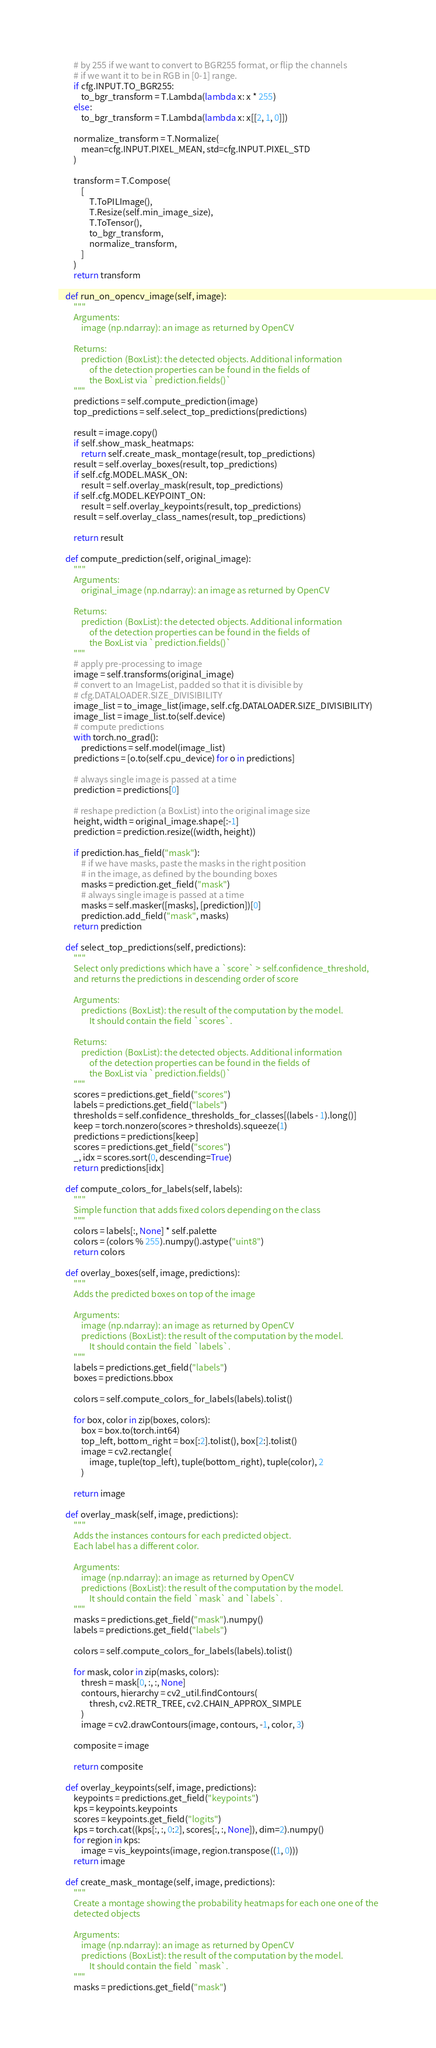<code> <loc_0><loc_0><loc_500><loc_500><_Python_>        # by 255 if we want to convert to BGR255 format, or flip the channels
        # if we want it to be in RGB in [0-1] range.
        if cfg.INPUT.TO_BGR255:
            to_bgr_transform = T.Lambda(lambda x: x * 255)
        else:
            to_bgr_transform = T.Lambda(lambda x: x[[2, 1, 0]])

        normalize_transform = T.Normalize(
            mean=cfg.INPUT.PIXEL_MEAN, std=cfg.INPUT.PIXEL_STD
        )

        transform = T.Compose(
            [
                T.ToPILImage(),
                T.Resize(self.min_image_size),
                T.ToTensor(),
                to_bgr_transform,
                normalize_transform,
            ]
        )
        return transform

    def run_on_opencv_image(self, image):
        """
        Arguments:
            image (np.ndarray): an image as returned by OpenCV

        Returns:
            prediction (BoxList): the detected objects. Additional information
                of the detection properties can be found in the fields of
                the BoxList via `prediction.fields()`
        """
        predictions = self.compute_prediction(image)
        top_predictions = self.select_top_predictions(predictions)

        result = image.copy()
        if self.show_mask_heatmaps:
            return self.create_mask_montage(result, top_predictions)
        result = self.overlay_boxes(result, top_predictions)
        if self.cfg.MODEL.MASK_ON:
            result = self.overlay_mask(result, top_predictions)
        if self.cfg.MODEL.KEYPOINT_ON:
            result = self.overlay_keypoints(result, top_predictions)
        result = self.overlay_class_names(result, top_predictions)

        return result

    def compute_prediction(self, original_image):
        """
        Arguments:
            original_image (np.ndarray): an image as returned by OpenCV

        Returns:
            prediction (BoxList): the detected objects. Additional information
                of the detection properties can be found in the fields of
                the BoxList via `prediction.fields()`
        """
        # apply pre-processing to image
        image = self.transforms(original_image)
        # convert to an ImageList, padded so that it is divisible by
        # cfg.DATALOADER.SIZE_DIVISIBILITY
        image_list = to_image_list(image, self.cfg.DATALOADER.SIZE_DIVISIBILITY)
        image_list = image_list.to(self.device)
        # compute predictions
        with torch.no_grad():
            predictions = self.model(image_list)
        predictions = [o.to(self.cpu_device) for o in predictions]

        # always single image is passed at a time
        prediction = predictions[0]

        # reshape prediction (a BoxList) into the original image size
        height, width = original_image.shape[:-1]
        prediction = prediction.resize((width, height))

        if prediction.has_field("mask"):
            # if we have masks, paste the masks in the right position
            # in the image, as defined by the bounding boxes
            masks = prediction.get_field("mask")
            # always single image is passed at a time
            masks = self.masker([masks], [prediction])[0]
            prediction.add_field("mask", masks)
        return prediction

    def select_top_predictions(self, predictions):
        """
        Select only predictions which have a `score` > self.confidence_threshold,
        and returns the predictions in descending order of score

        Arguments:
            predictions (BoxList): the result of the computation by the model.
                It should contain the field `scores`.

        Returns:
            prediction (BoxList): the detected objects. Additional information
                of the detection properties can be found in the fields of
                the BoxList via `prediction.fields()`
        """
        scores = predictions.get_field("scores")
        labels = predictions.get_field("labels")
        thresholds = self.confidence_thresholds_for_classes[(labels - 1).long()]
        keep = torch.nonzero(scores > thresholds).squeeze(1)
        predictions = predictions[keep]
        scores = predictions.get_field("scores")
        _, idx = scores.sort(0, descending=True)
        return predictions[idx]

    def compute_colors_for_labels(self, labels):
        """
        Simple function that adds fixed colors depending on the class
        """
        colors = labels[:, None] * self.palette
        colors = (colors % 255).numpy().astype("uint8")
        return colors

    def overlay_boxes(self, image, predictions):
        """
        Adds the predicted boxes on top of the image

        Arguments:
            image (np.ndarray): an image as returned by OpenCV
            predictions (BoxList): the result of the computation by the model.
                It should contain the field `labels`.
        """
        labels = predictions.get_field("labels")
        boxes = predictions.bbox

        colors = self.compute_colors_for_labels(labels).tolist()

        for box, color in zip(boxes, colors):
            box = box.to(torch.int64)
            top_left, bottom_right = box[:2].tolist(), box[2:].tolist()
            image = cv2.rectangle(
                image, tuple(top_left), tuple(bottom_right), tuple(color), 2
            )

        return image

    def overlay_mask(self, image, predictions):
        """
        Adds the instances contours for each predicted object.
        Each label has a different color.

        Arguments:
            image (np.ndarray): an image as returned by OpenCV
            predictions (BoxList): the result of the computation by the model.
                It should contain the field `mask` and `labels`.
        """
        masks = predictions.get_field("mask").numpy()
        labels = predictions.get_field("labels")

        colors = self.compute_colors_for_labels(labels).tolist()

        for mask, color in zip(masks, colors):
            thresh = mask[0, :, :, None]
            contours, hierarchy = cv2_util.findContours(
                thresh, cv2.RETR_TREE, cv2.CHAIN_APPROX_SIMPLE
            )
            image = cv2.drawContours(image, contours, -1, color, 3)

        composite = image

        return composite

    def overlay_keypoints(self, image, predictions):
        keypoints = predictions.get_field("keypoints")
        kps = keypoints.keypoints
        scores = keypoints.get_field("logits")
        kps = torch.cat((kps[:, :, 0:2], scores[:, :, None]), dim=2).numpy()
        for region in kps:
            image = vis_keypoints(image, region.transpose((1, 0)))
        return image

    def create_mask_montage(self, image, predictions):
        """
        Create a montage showing the probability heatmaps for each one one of the
        detected objects

        Arguments:
            image (np.ndarray): an image as returned by OpenCV
            predictions (BoxList): the result of the computation by the model.
                It should contain the field `mask`.
        """
        masks = predictions.get_field("mask")</code> 